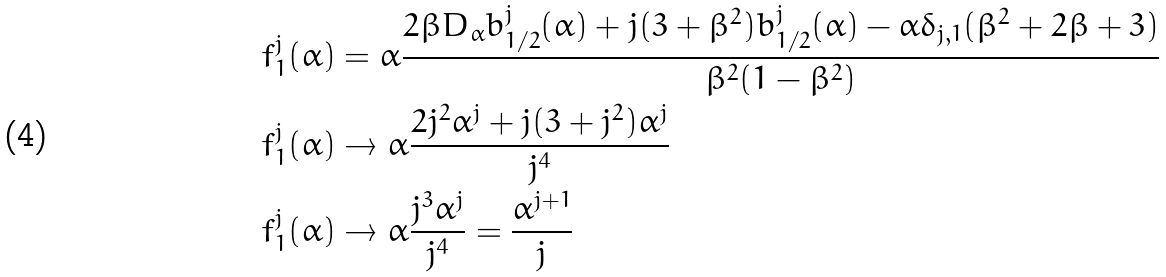<formula> <loc_0><loc_0><loc_500><loc_500>f _ { 1 } ^ { j } ( \alpha ) & = \alpha \frac { 2 \beta D _ { \alpha } b ^ { j } _ { 1 / 2 } ( \alpha ) + j ( 3 + \beta ^ { 2 } ) b ^ { j } _ { 1 / 2 } ( \alpha ) - \alpha \delta _ { j , 1 } ( \beta ^ { 2 } + 2 \beta + 3 ) } { \beta ^ { 2 } ( 1 - \beta ^ { 2 } ) } \\ f _ { 1 } ^ { j } ( \alpha ) & \rightarrow \alpha \frac { 2 j ^ { 2 } \alpha ^ { j } + j ( 3 + j ^ { 2 } ) \alpha ^ { j } } { j ^ { 4 } } \\ f _ { 1 } ^ { j } ( \alpha ) & \rightarrow \alpha \frac { j ^ { 3 } \alpha ^ { j } } { j ^ { 4 } } = \frac { \alpha ^ { j + 1 } } { j }</formula> 